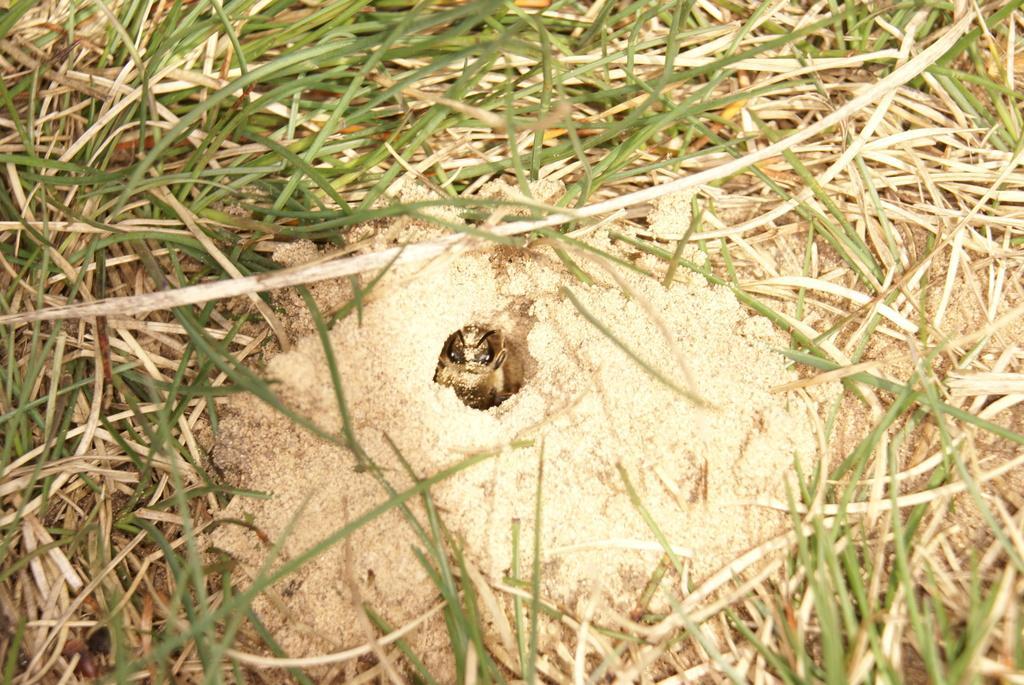Could you give a brief overview of what you see in this image? In this image I can see in the middle it looks like an insect and there is the grass in this image. 